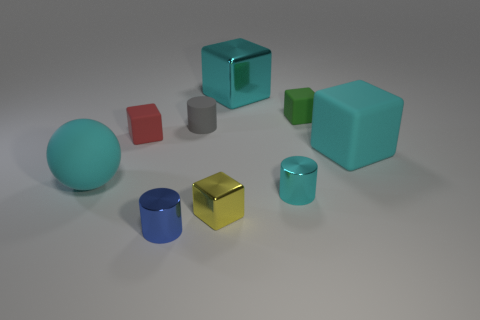Is the color of the small metal cylinder on the right side of the small blue metal cylinder the same as the shiny thing that is behind the green rubber thing?
Keep it short and to the point. Yes. What size is the metal cylinder that is the same color as the large rubber block?
Your answer should be compact. Small. Are there any tiny blue metal things?
Offer a terse response. Yes. There is a large cyan matte thing that is to the left of the tiny shiny thing on the right side of the metallic cube in front of the tiny matte cylinder; what shape is it?
Give a very brief answer. Sphere. There is a matte ball; what number of small blocks are in front of it?
Your answer should be very brief. 1. Does the tiny yellow thing that is in front of the big cyan metal block have the same material as the blue cylinder?
Give a very brief answer. Yes. What number of other objects are the same shape as the yellow thing?
Give a very brief answer. 4. How many small red matte things are in front of the cyan thing that is behind the small green cube that is on the right side of the yellow metallic cube?
Keep it short and to the point. 1. What is the color of the large rubber sphere to the left of the red matte block?
Offer a terse response. Cyan. Do the tiny cylinder that is in front of the tiny cyan metallic thing and the big sphere have the same color?
Provide a succinct answer. No. 